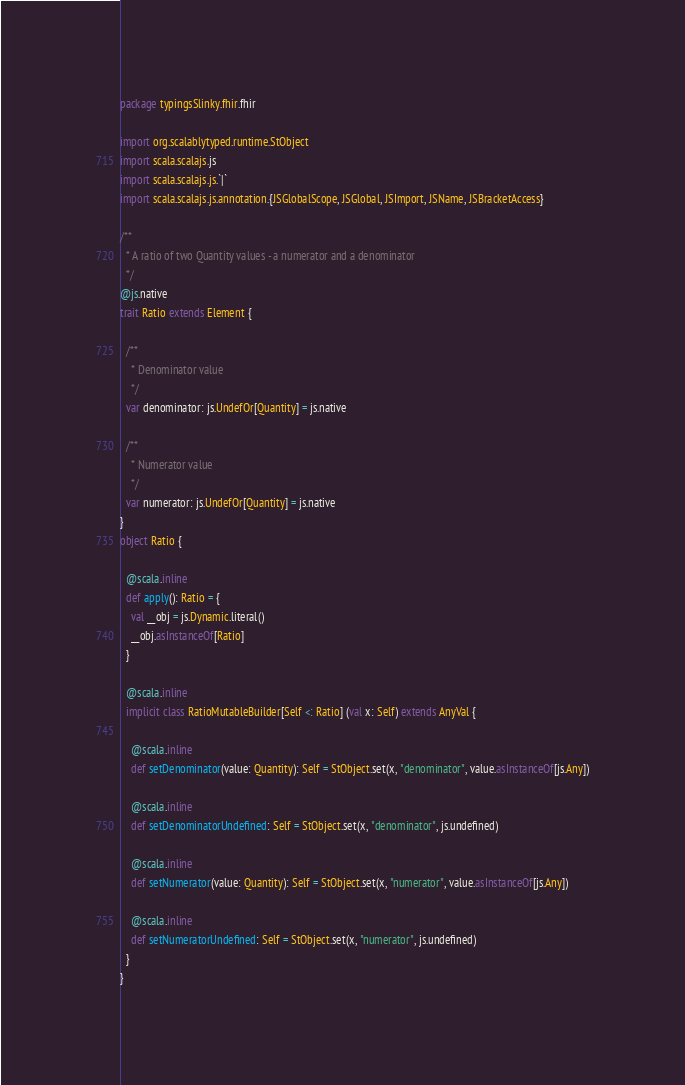<code> <loc_0><loc_0><loc_500><loc_500><_Scala_>package typingsSlinky.fhir.fhir

import org.scalablytyped.runtime.StObject
import scala.scalajs.js
import scala.scalajs.js.`|`
import scala.scalajs.js.annotation.{JSGlobalScope, JSGlobal, JSImport, JSName, JSBracketAccess}

/**
  * A ratio of two Quantity values - a numerator and a denominator
  */
@js.native
trait Ratio extends Element {
  
  /**
    * Denominator value
    */
  var denominator: js.UndefOr[Quantity] = js.native
  
  /**
    * Numerator value
    */
  var numerator: js.UndefOr[Quantity] = js.native
}
object Ratio {
  
  @scala.inline
  def apply(): Ratio = {
    val __obj = js.Dynamic.literal()
    __obj.asInstanceOf[Ratio]
  }
  
  @scala.inline
  implicit class RatioMutableBuilder[Self <: Ratio] (val x: Self) extends AnyVal {
    
    @scala.inline
    def setDenominator(value: Quantity): Self = StObject.set(x, "denominator", value.asInstanceOf[js.Any])
    
    @scala.inline
    def setDenominatorUndefined: Self = StObject.set(x, "denominator", js.undefined)
    
    @scala.inline
    def setNumerator(value: Quantity): Self = StObject.set(x, "numerator", value.asInstanceOf[js.Any])
    
    @scala.inline
    def setNumeratorUndefined: Self = StObject.set(x, "numerator", js.undefined)
  }
}
</code> 